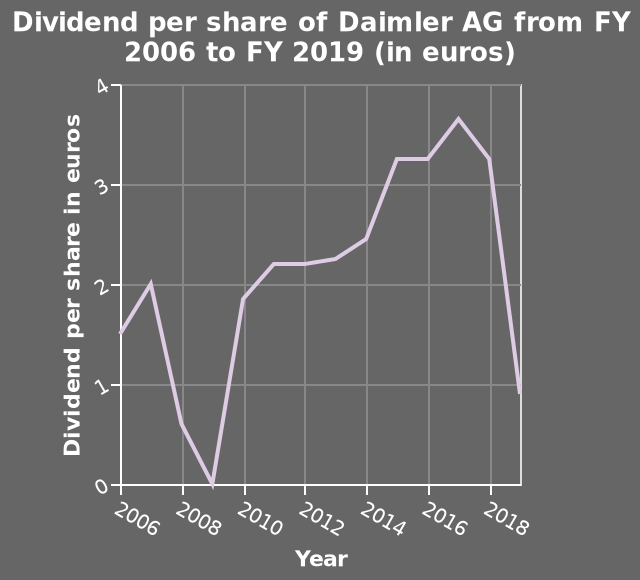<image>
When did the dividend per share experience a steep drop?  The dividend per share experienced a steep drop by 2019. What is the title of this line diagram?  The title of this line diagram is "Dividend per share of Daimler AG from FY 2006 to FY 2019 (in euros)". 